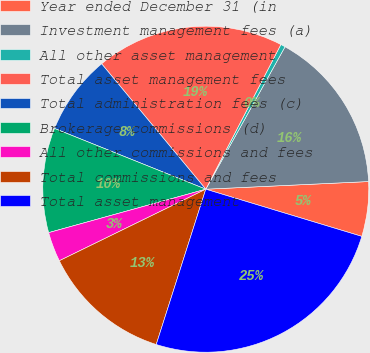Convert chart. <chart><loc_0><loc_0><loc_500><loc_500><pie_chart><fcel>Year ended December 31 (in<fcel>Investment management fees (a)<fcel>All other asset management<fcel>Total asset management fees<fcel>Total administration fees (c)<fcel>Brokerage commissions (d)<fcel>All other commissions and fees<fcel>Total commissions and fees<fcel>Total asset management<nl><fcel>5.42%<fcel>16.17%<fcel>0.46%<fcel>18.65%<fcel>7.89%<fcel>10.37%<fcel>2.94%<fcel>12.85%<fcel>25.24%<nl></chart> 